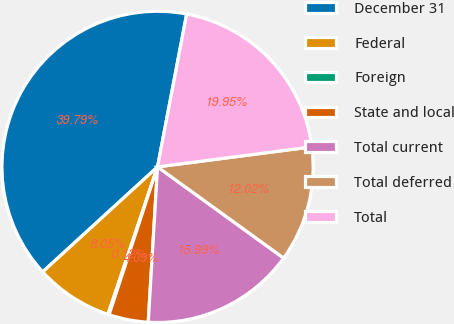Convert chart to OTSL. <chart><loc_0><loc_0><loc_500><loc_500><pie_chart><fcel>December 31<fcel>Federal<fcel>Foreign<fcel>State and local<fcel>Total current<fcel>Total deferred<fcel>Total<nl><fcel>39.79%<fcel>8.05%<fcel>0.12%<fcel>4.09%<fcel>15.99%<fcel>12.02%<fcel>19.95%<nl></chart> 